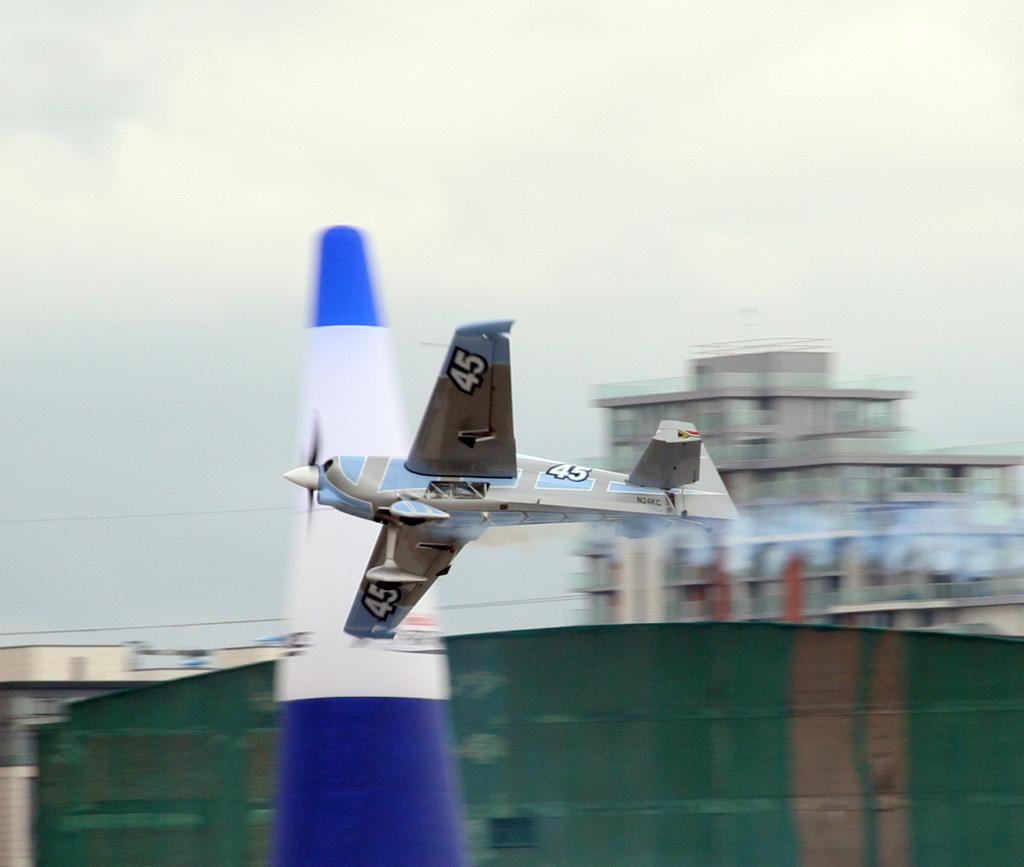<image>
Create a compact narrative representing the image presented. A silver plane with the number 45 painted on it in multiple places. 